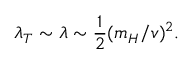Convert formula to latex. <formula><loc_0><loc_0><loc_500><loc_500>\lambda _ { T } \sim \lambda \sim \frac { 1 } { 2 } ( m _ { H } / v ) ^ { 2 } .</formula> 